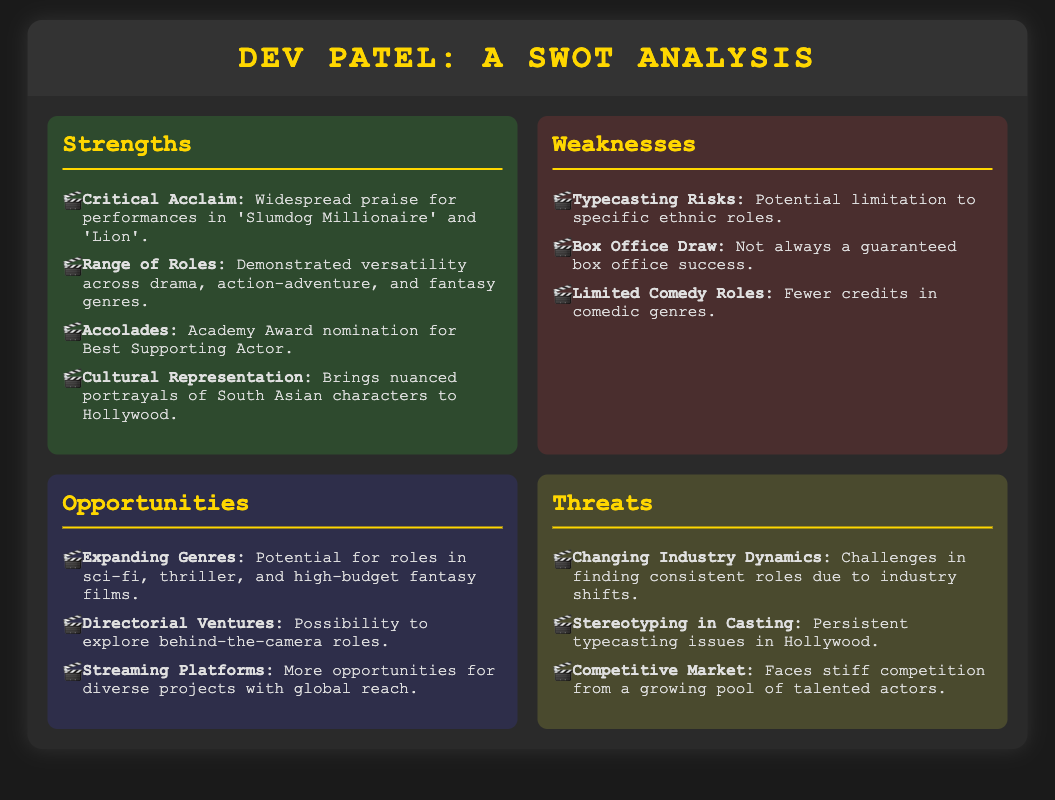what is one of Dev Patel's strengths as an actor? The document lists Critical Acclaim, Range of Roles, Accolades, and Cultural Representation as strengths.
Answer: Critical Acclaim how many weaknesses are listed for Dev Patel? The document includes three weaknesses: Typecasting Risks, Box Office Draw, and Limited Comedy Roles.
Answer: Three what award was Dev Patel nominated for? The document mentions that he received an Academy Award nomination for Best Supporting Actor.
Answer: Academy Award name one opportunity available to Dev Patel. The document lists Expanding Genres, Directorial Ventures, and Streaming Platforms as opportunities.
Answer: Expanding Genres what is a threat to Dev Patel's acting career? The document identifies Changing Industry Dynamics, Stereotyping in Casting, and Competitive Market as threats.
Answer: Changing Industry Dynamics which genre roles does the document suggest Dev Patel has limited experience in? The document highlights Limited Comedy Roles as a specific weakness.
Answer: Comedy what accolade does the document highlight in Dev Patel's strengths? The document includes Accolades with a specific mention of an Academy Award nomination.
Answer: Academy Award nomination what type of roles does the document suggest might be a risk for Dev Patel? The document notes Typecasting Risks as a weakness that could limit his opportunities.
Answer: Typecasting Risks 